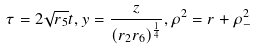<formula> <loc_0><loc_0><loc_500><loc_500>\tau = 2 \sqrt { r _ { 5 } } t , y = \frac { z } { ( r _ { 2 } r _ { 6 } ) ^ { \frac { 1 } { 4 } } } , \rho ^ { 2 } = r + \rho _ { - } ^ { 2 }</formula> 